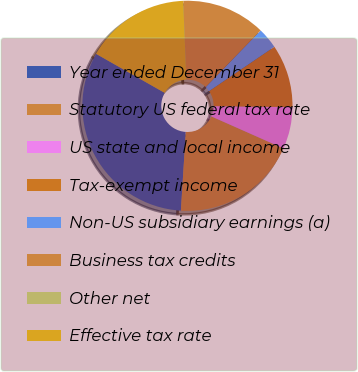<chart> <loc_0><loc_0><loc_500><loc_500><pie_chart><fcel>Year ended December 31<fcel>Statutory US federal tax rate<fcel>US state and local income<fcel>Tax-exempt income<fcel>Non-US subsidiary earnings (a)<fcel>Business tax credits<fcel>Other net<fcel>Effective tax rate<nl><fcel>32.24%<fcel>19.35%<fcel>6.46%<fcel>9.68%<fcel>3.24%<fcel>12.9%<fcel>0.01%<fcel>16.12%<nl></chart> 